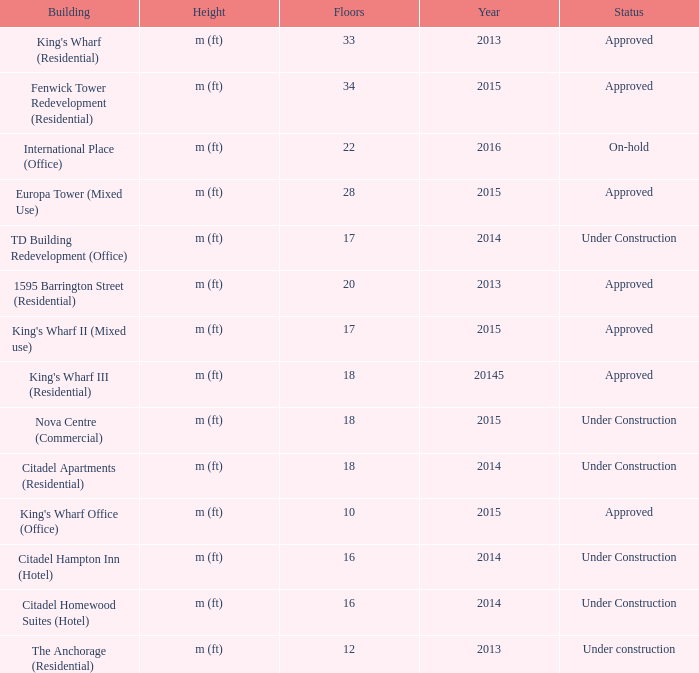What is the status of the building for 2014 with 33 floors? Approved. 